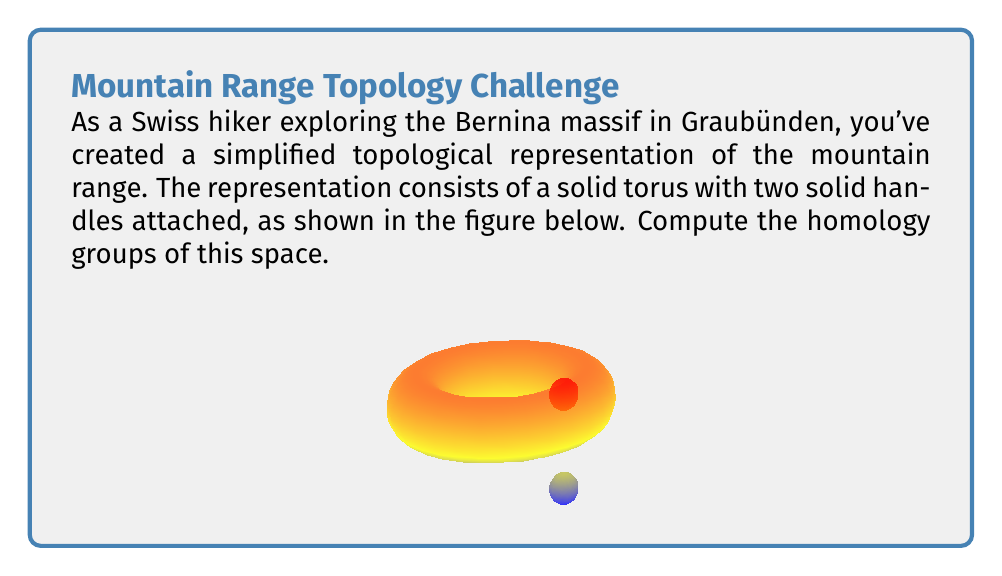Could you help me with this problem? To compute the homology groups of this space, we'll follow these steps:

1) First, let's identify the space. It's a solid torus with two solid handles attached, which is homotopy equivalent to a torus with two additional 1-cells attached.

2) We can use the cellular homology approach. Let's count the cells:
   - 0-cells: 1 (the base point)
   - 1-cells: 3 (two from the torus, one for each handle)
   - 2-cells: 1 (the surface of the torus)

3) Now, let's compute the homology groups:

   For $H_0$:
   The 0th homology group is always $\mathbb{Z}$ for a connected space.
   $H_0 = \mathbb{Z}$

   For $H_1$:
   We have three 1-cells and no boundary maps from 2-cells that affect them.
   $H_1 = \mathbb{Z} \oplus \mathbb{Z} \oplus \mathbb{Z}$

   For $H_2$:
   We have one 2-cell, and its boundary is trivial in homology.
   $H_2 = \mathbb{Z}$

   For $H_n$ where $n \geq 3$:
   There are no cells of dimension 3 or higher, so these homology groups are trivial.
   $H_n = 0$ for $n \geq 3$

4) Therefore, the homology groups of this space are:
   $H_0 = \mathbb{Z}$
   $H_1 = \mathbb{Z} \oplus \mathbb{Z} \oplus \mathbb{Z}$
   $H_2 = \mathbb{Z}$
   $H_n = 0$ for $n \geq 3$
Answer: $H_0 = \mathbb{Z}$, $H_1 = \mathbb{Z}^3$, $H_2 = \mathbb{Z}$, $H_n = 0$ for $n \geq 3$ 